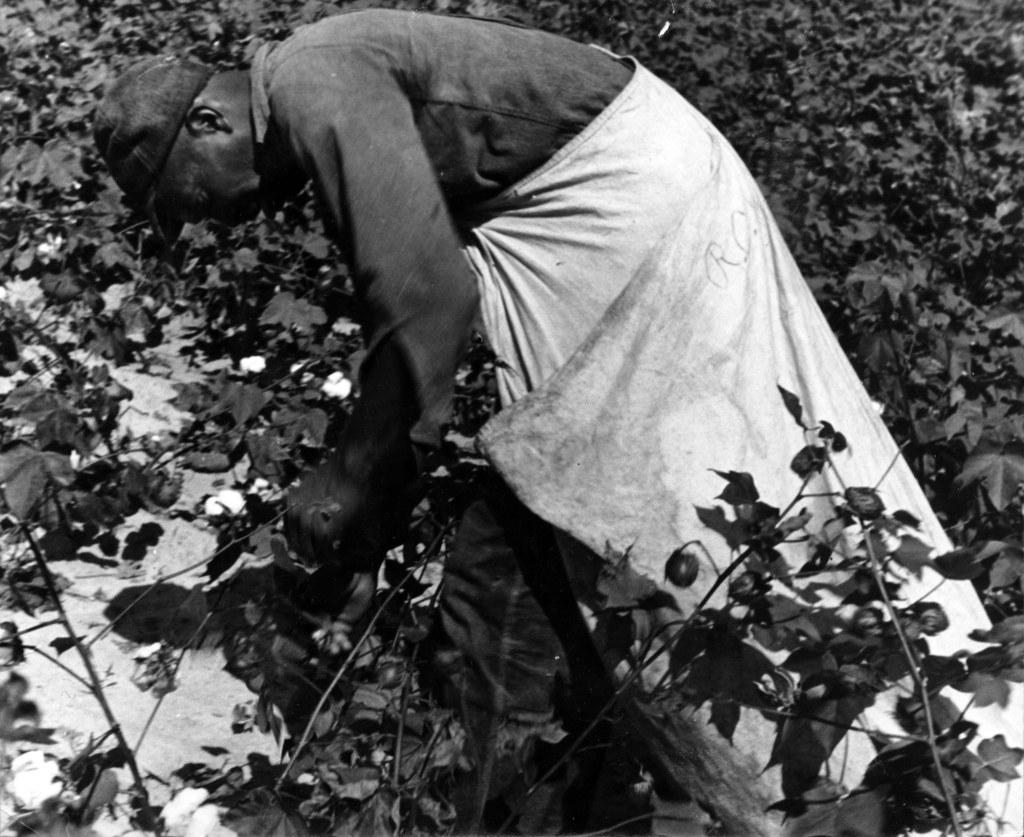What is the color scheme of the image? The image is black and white. Who is present in the image? There is a man in the image. What is the man wearing on his head? The man is wearing a cap. What type of vegetation can be seen in the image? There are plants in the image. What color is the man's clothing? The man is wearing white-colored clothing. Can you see the ocean in the image? No, the ocean is not present in the image. Is there a wall visible in the image? No, there is no wall visible in the image. 